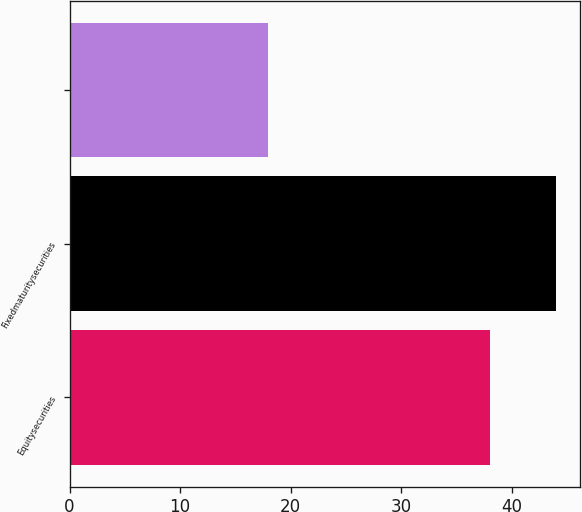<chart> <loc_0><loc_0><loc_500><loc_500><bar_chart><fcel>Equitysecurities<fcel>Fixedmaturitysecurities<fcel>Unnamed: 2<nl><fcel>38<fcel>44<fcel>18<nl></chart> 